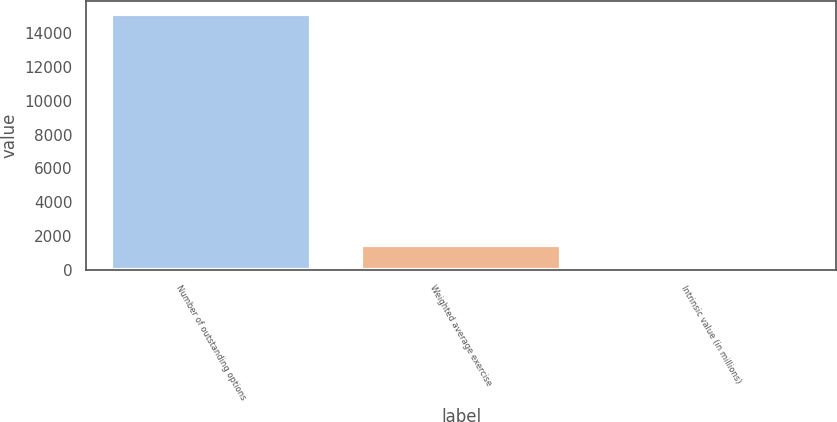Convert chart to OTSL. <chart><loc_0><loc_0><loc_500><loc_500><bar_chart><fcel>Number of outstanding options<fcel>Weighted average exercise<fcel>Intrinsic value (in millions)<nl><fcel>15096<fcel>1520.58<fcel>12.2<nl></chart> 